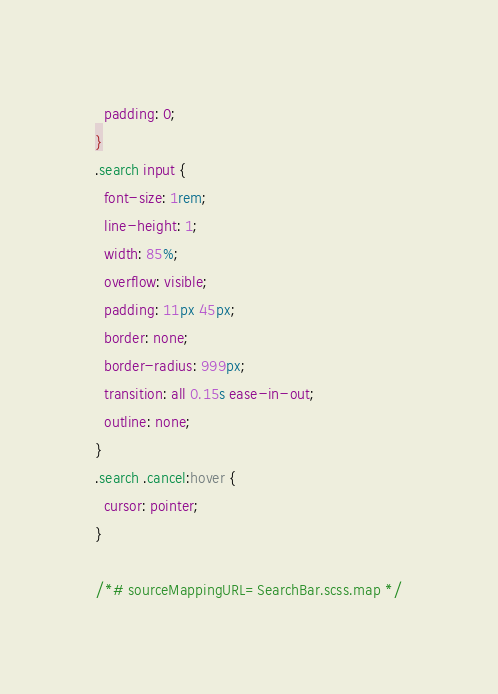Convert code to text. <code><loc_0><loc_0><loc_500><loc_500><_CSS_>  padding: 0;
}
.search input {
  font-size: 1rem;
  line-height: 1;
  width: 85%;
  overflow: visible;
  padding: 11px 45px;
  border: none;
  border-radius: 999px;
  transition: all 0.15s ease-in-out;
  outline: none;
}
.search .cancel:hover {
  cursor: pointer;
}

/*# sourceMappingURL=SearchBar.scss.map */
</code> 